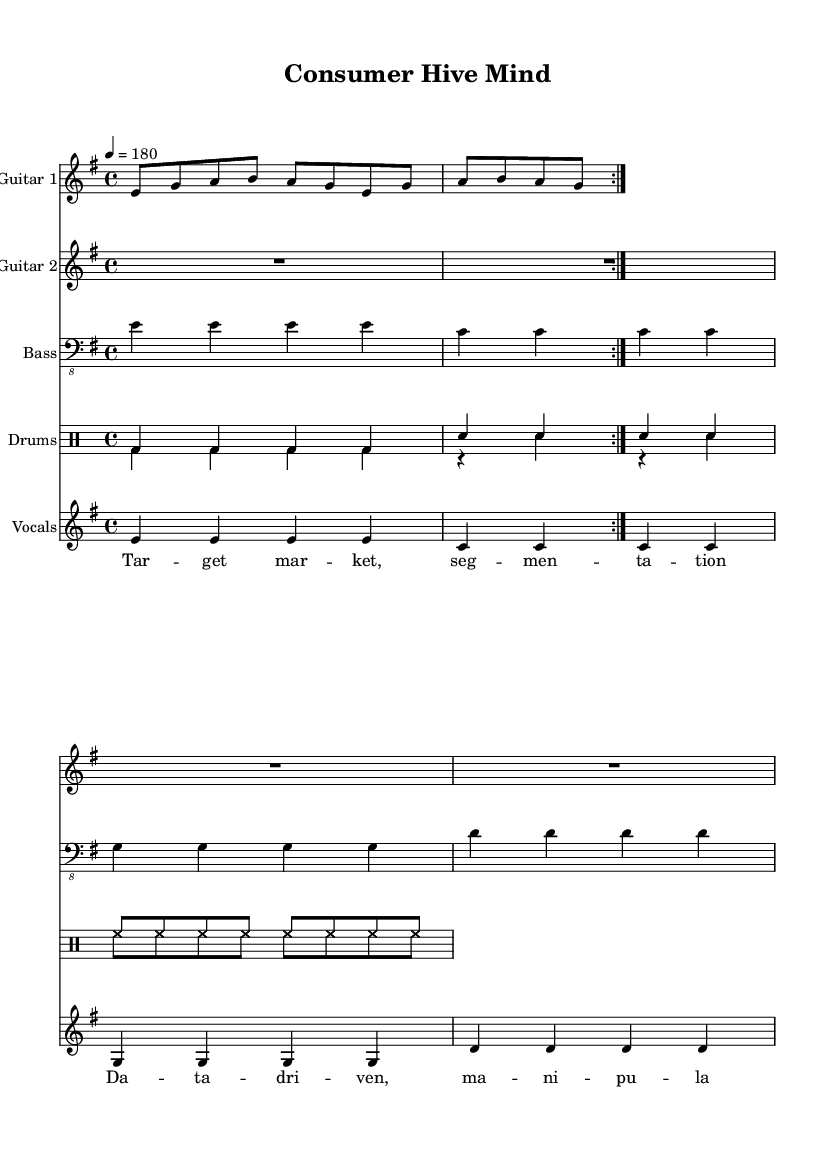What is the key signature of this music? The key signature appears at the beginning of the music, which indicates E minor, as indicated by one sharp (F#) in the key signature.
Answer: E minor What is the time signature of this music? The time signature is located after the key signature, written as 4/4, which means there are four beats in each measure and a quarter note receives one beat.
Answer: 4/4 What is the tempo marking for this piece? The tempo marking is indicated at the start of the music as 4 = 180, meaning the quarter note should be played at 180 beats per minute.
Answer: 180 How many guitar parts are there? By analyzing the score, there are two distinct guitar parts labeled Guitar 1 and Guitar 2.
Answer: Two What is the primary theme of the lyrics in this music? The lyrics mention marketing strategies and consumer behavior, particularly referring to tactics like segmentation and data-driven manipulation, suggesting a critique of marketing practices.
Answer: Marketing strategies What is the main rhythmic pattern used in the drums? Looking at the drum staff, the primary rhythmic pattern consists of a consistent bass drum on the quarter notes and snare on alternate beats within a measure, creating a driving rhythm typical of metal music.
Answer: Bass and snare rhythm What kind of vocal style is likely used for this piece? The high energy and aggressive nature suggested by the tempo, rhythm, and themes imply a harsh vocal style typical of metal, which often includes shouting or growling, resonating with the aggressive tone of the lyrics.
Answer: Aggressive vocal style 